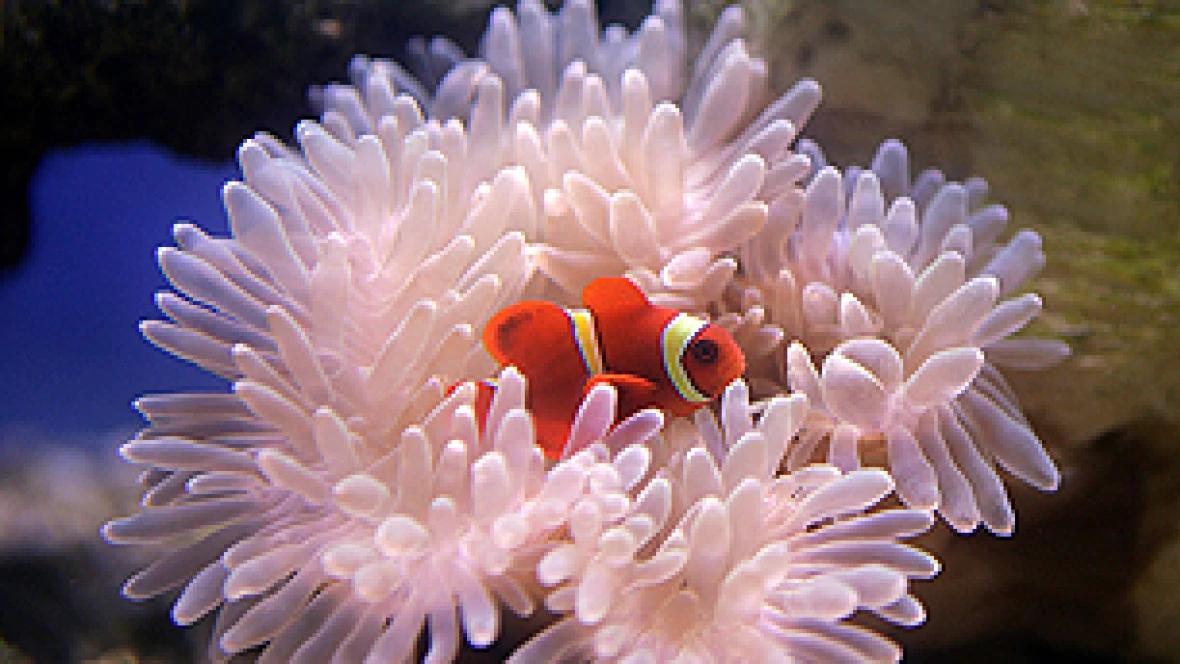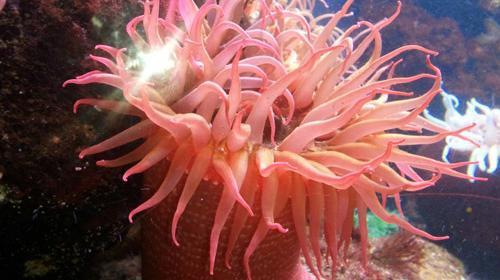The first image is the image on the left, the second image is the image on the right. Examine the images to the left and right. Is the description "The anemone in one of the images is a translucent pink." accurate? Answer yes or no. Yes. 